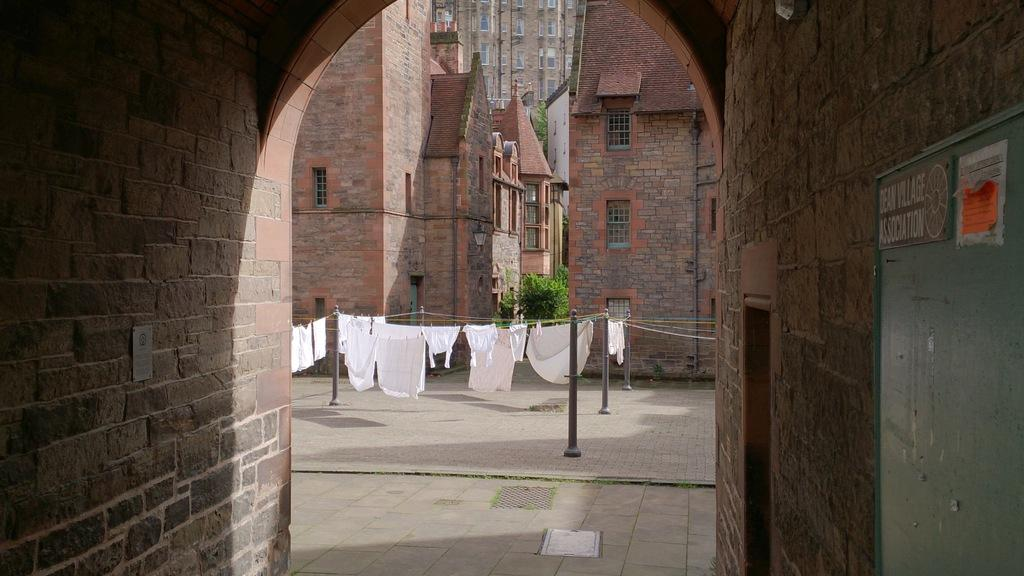What type of structures can be seen in the image? There are buildings in the image. What other natural elements are present in the image? There are trees in the image. What are the clothes hanging on in the image? The clothes are hanging on ropes. What type of vertical structures can be seen in the image? There are poles in the image. What is attached to a wall in the image? There is a board attached to a wall. How many pigs are visible on the board in the image? There are no pigs present in the image, and the board does not have any pigs on it. What type of gold jewelry is the uncle wearing in the image? There is no uncle or gold jewelry present in the image. 